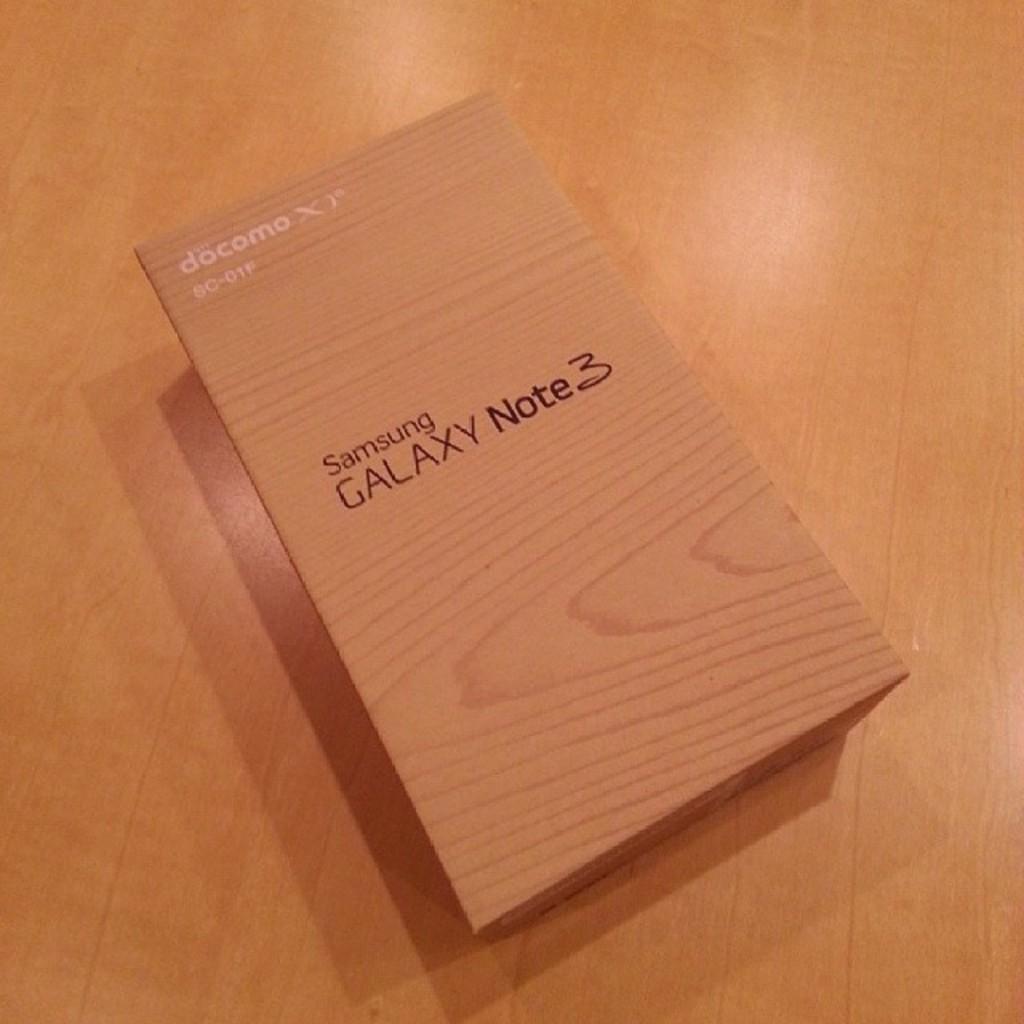What is the model of this phone in the box?
Your answer should be compact. Galaxy note 3. Who made the phone?
Your answer should be very brief. Samsung. 